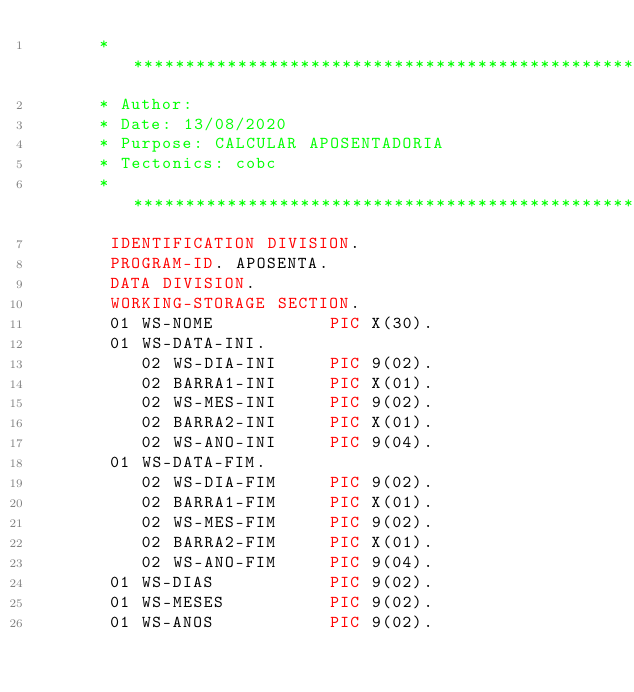<code> <loc_0><loc_0><loc_500><loc_500><_COBOL_>      ******************************************************************
      * Author:
      * Date: 13/08/2020
      * Purpose: CALCULAR APOSENTADORIA
      * Tectonics: cobc
      ******************************************************************
       IDENTIFICATION DIVISION.
       PROGRAM-ID. APOSENTA.
       DATA DIVISION.
       WORKING-STORAGE SECTION.
       01 WS-NOME           PIC X(30).
       01 WS-DATA-INI.
          02 WS-DIA-INI     PIC 9(02).
          02 BARRA1-INI     PIC X(01).
          02 WS-MES-INI     PIC 9(02).
          02 BARRA2-INI     PIC X(01).
          02 WS-ANO-INI     PIC 9(04).
       01 WS-DATA-FIM.
          02 WS-DIA-FIM     PIC 9(02).
          02 BARRA1-FIM     PIC X(01).
          02 WS-MES-FIM     PIC 9(02).
          02 BARRA2-FIM     PIC X(01).
          02 WS-ANO-FIM     PIC 9(04).
       01 WS-DIAS           PIC 9(02).
       01 WS-MESES          PIC 9(02).
       01 WS-ANOS           PIC 9(02).</code> 